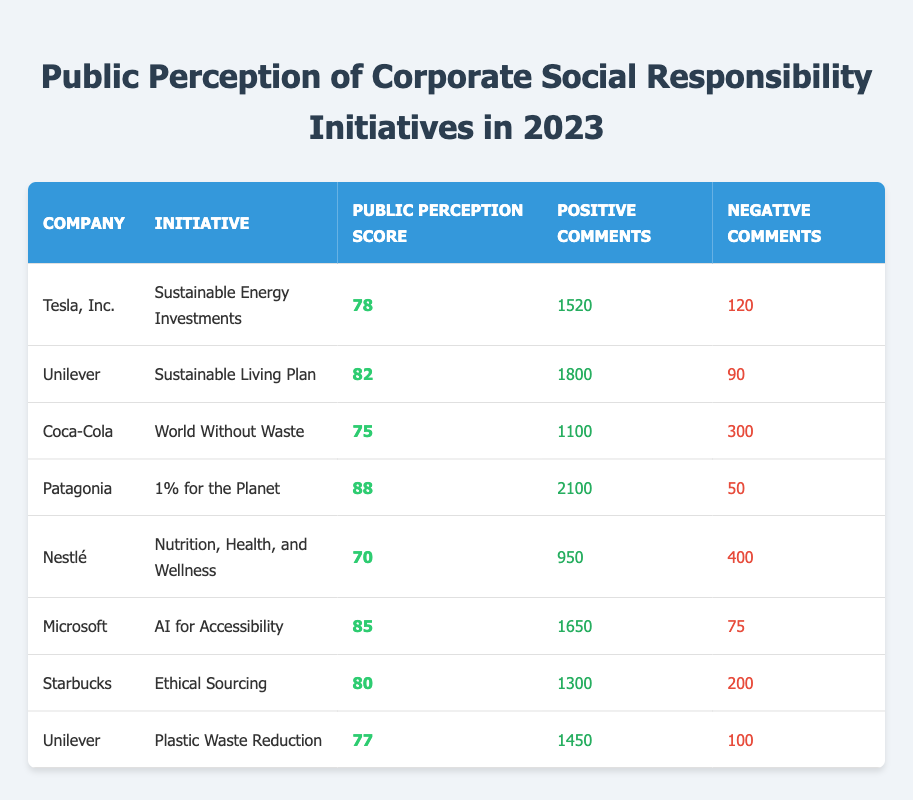What is the public perception score of Patagonia's initiative? According to the table, Patagonia's initiative "1% for the Planet" has a public perception score of 88.
Answer: 88 Which company received the highest number of positive comments? By reviewing the table, Patagonia received the highest number of positive comments at 2100.
Answer: Patagonia How many negative comments did Coca-Cola receive? The table shows that Coca-Cola's "World Without Waste" initiative received 300 negative comments.
Answer: 300 What is the average public perception score of Nestlé and Coca-Cola? Nestlé has a score of 70 and Coca-Cola has a score of 75. The average is (70 + 75) / 2 = 72.5.
Answer: 72.5 Is Unilever's "Sustainable Living Plan" initiative viewed more positively than its "Plastic Waste Reduction" initiative? The scores are 82 for the "Sustainable Living Plan" and 77 for "Plastic Waste Reduction"; hence, it is viewed more positively.
Answer: Yes Which company has the lowest public perception score and what is it? The lowest score in the table is 70 for Nestlé's "Nutrition, Health, and Wellness."
Answer: 70, Nestlé What is the total number of positive comments across all initiatives? Summing up all positive comments: 1520 + 1800 + 1100 + 2100 + 950 + 1650 + 1300 + 1450 =  11070.
Answer: 11070 If we compare Microsoft and Coca-Cola, how many fewer negative comments does Microsoft have? Microsoft has 75 negative comments while Coca-Cola has 300. The difference is 300 - 75 = 225.
Answer: 225 What is the public perception score of Tesla compared to the average score of all companies listed? Tesla's score is 78. The average score can be calculated as (78 + 82 + 75 + 88 + 70 + 85 + 80 + 77) / 8 = 78.125. Tesla is slightly below the average.
Answer: Below average Among the companies listed, which initiative had the highest positive-to-negative comments ratio? For each initiative, calculate the ratio of positive to negative comments. Patagonia has 2100/50 = 42, which is the highest ratio.
Answer: Patagonia 